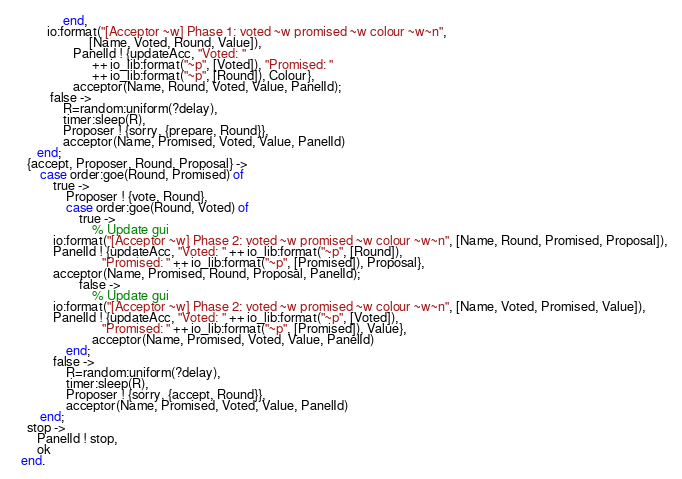<code> <loc_0><loc_0><loc_500><loc_500><_Erlang_>               end,                
		  io:format("[Acceptor ~w] Phase 1: voted ~w promised ~w colour ~w~n",
                       [Name, Voted, Round, Value]),
                  PanelId ! {updateAcc, "Voted: " 
                        ++ io_lib:format("~p", [Voted]), "Promised: " 
                        ++ io_lib:format("~p", [Round]), Colour},
                  acceptor(Name, Round, Voted, Value, PanelId);
           false ->
               R=random:uniform(?delay),
               timer:sleep(R),
               Proposer ! {sorry, {prepare, Round}},
               acceptor(Name, Promised, Voted, Value, PanelId)
       end;
    {accept, Proposer, Round, Proposal} ->
        case order:goe(Round, Promised) of
            true ->
                Proposer ! {vote, Round},
                case order:goe(Round, Voted) of
                    true ->
                    	% Update gui
			io:format("[Acceptor ~w] Phase 2: voted ~w promised ~w colour ~w~n", [Name, Round, Promised, Proposal]),
			PanelId ! {updateAcc, "Voted: " ++ io_lib:format("~p", [Round]), 
                           "Promised: " ++ io_lib:format("~p", [Promised]), Proposal},
			acceptor(Name, Promised, Round, Proposal, PanelId);
                    false ->
                        % Update gui
			io:format("[Acceptor ~w] Phase 2: voted ~w promised ~w colour ~w~n", [Name, Voted, Promised, Value]),
			PanelId ! {updateAcc, "Voted: " ++ io_lib:format("~p", [Voted]), 
                           "Promised: " ++ io_lib:format("~p", [Promised]), Value},
                        acceptor(Name, Promised, Voted, Value, PanelId)
                end;   
            false ->
                R=random:uniform(?delay),
                timer:sleep(R),
                Proposer ! {sorry, {accept, Round}},
                acceptor(Name, Promised, Voted, Value, PanelId)
        end;
    stop ->
       PanelId ! stop,
       ok
  end.
</code> 